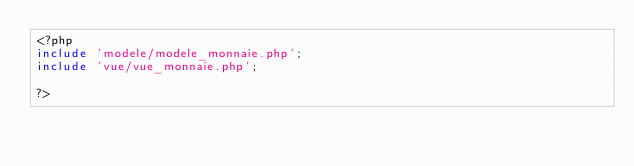Convert code to text. <code><loc_0><loc_0><loc_500><loc_500><_PHP_><?php 
include 'modele/modele_monnaie.php';
include 'vue/vue_monnaie.php';

?></code> 